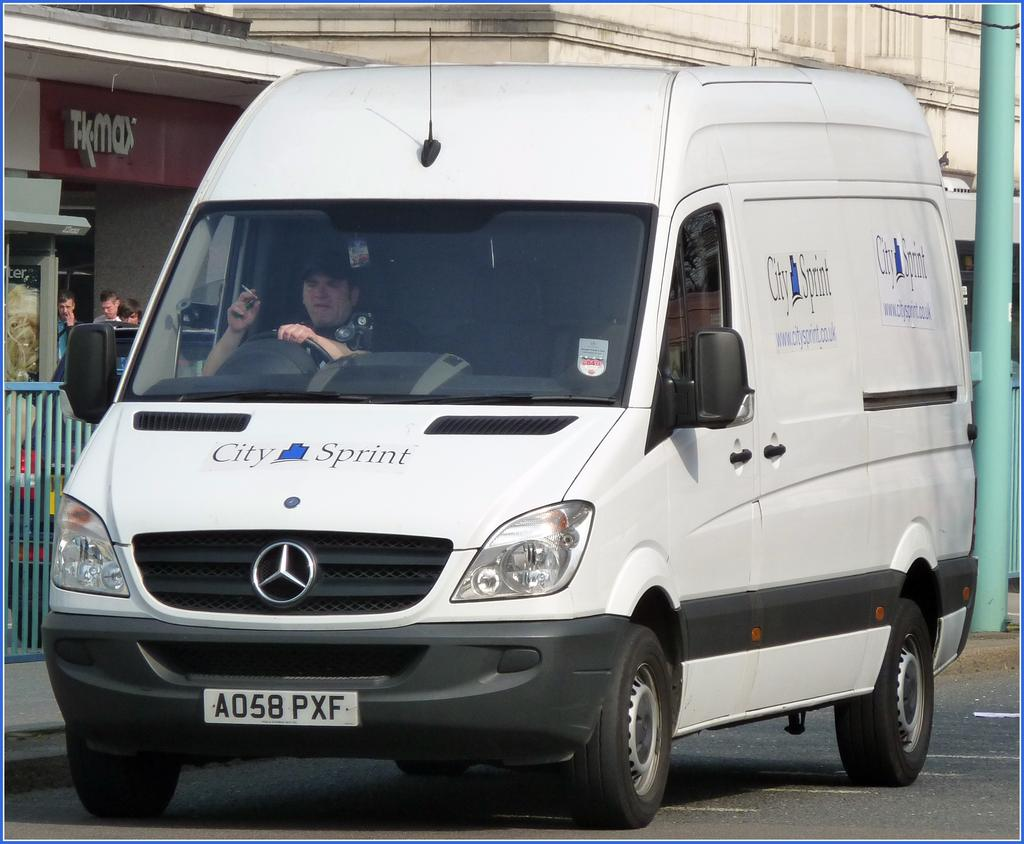Provide a one-sentence caption for the provided image. A white van that says City of Sprint on it. 